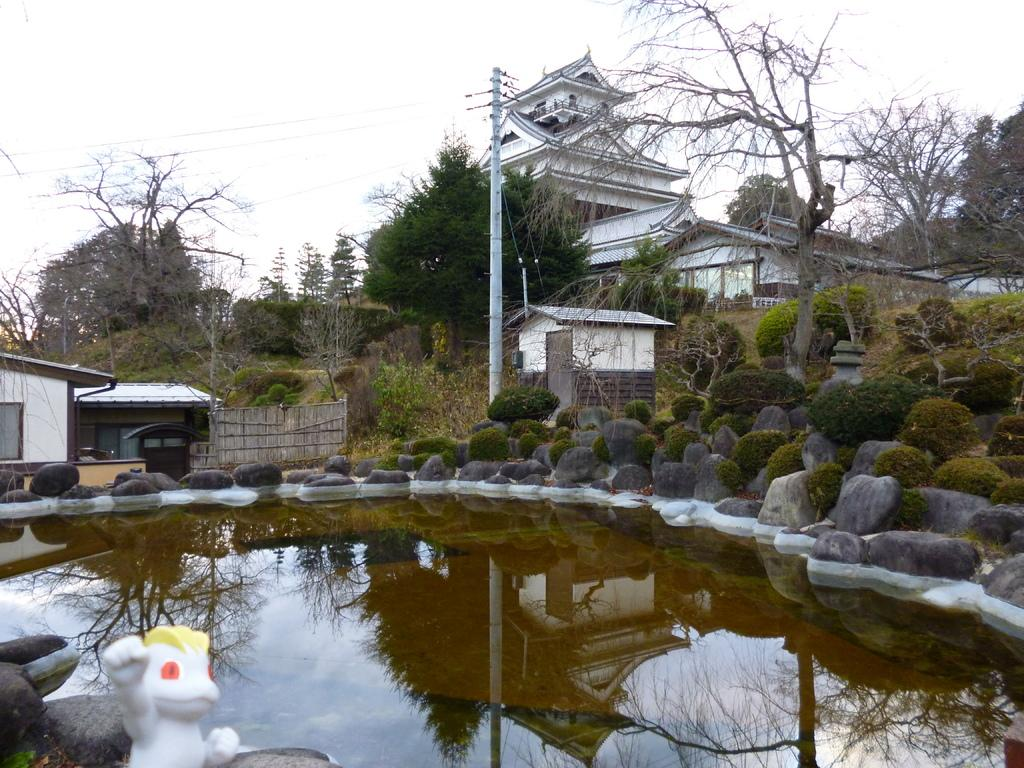What is the primary element visible in the image? There is water in the image. What other objects can be seen in the image? There are stones, trees, buildings, and a pole visible in the image. What is the background of the image? The sky is visible in the background of the image. What note is the vessel playing in the image? There is no vessel or note present in the image. 